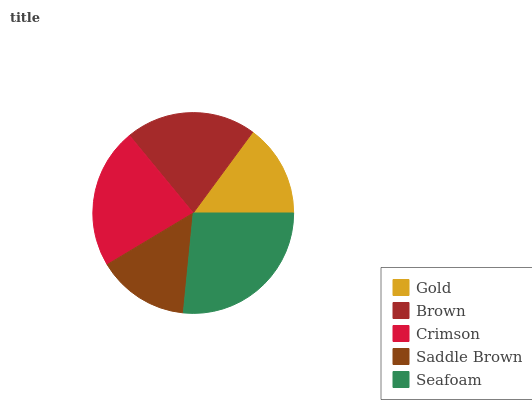Is Saddle Brown the minimum?
Answer yes or no. Yes. Is Seafoam the maximum?
Answer yes or no. Yes. Is Brown the minimum?
Answer yes or no. No. Is Brown the maximum?
Answer yes or no. No. Is Brown greater than Gold?
Answer yes or no. Yes. Is Gold less than Brown?
Answer yes or no. Yes. Is Gold greater than Brown?
Answer yes or no. No. Is Brown less than Gold?
Answer yes or no. No. Is Brown the high median?
Answer yes or no. Yes. Is Brown the low median?
Answer yes or no. Yes. Is Saddle Brown the high median?
Answer yes or no. No. Is Gold the low median?
Answer yes or no. No. 